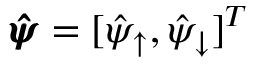Convert formula to latex. <formula><loc_0><loc_0><loc_500><loc_500>\pm b { \hat { \psi } } = [ \hat { \psi } _ { \uparrow } , \hat { \psi } _ { \downarrow } ] ^ { T }</formula> 